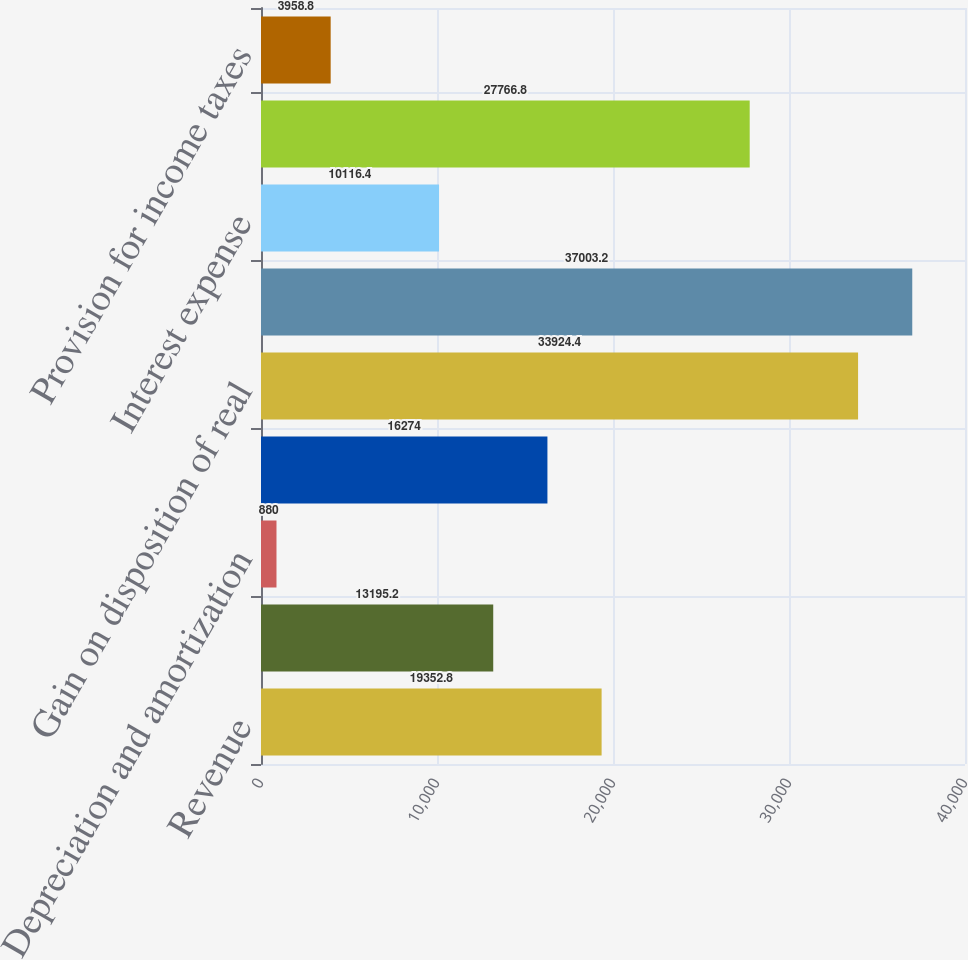Convert chart to OTSL. <chart><loc_0><loc_0><loc_500><loc_500><bar_chart><fcel>Revenue<fcel>Operating administrative and<fcel>Depreciation and amortization<fcel>Total costs and expenses<fcel>Gain on disposition of real<fcel>Operating income<fcel>Interest expense<fcel>Income from discontinued<fcel>Provision for income taxes<nl><fcel>19352.8<fcel>13195.2<fcel>880<fcel>16274<fcel>33924.4<fcel>37003.2<fcel>10116.4<fcel>27766.8<fcel>3958.8<nl></chart> 